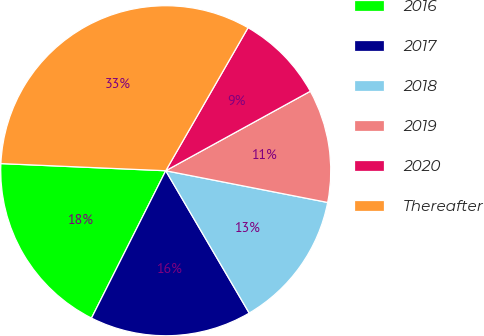<chart> <loc_0><loc_0><loc_500><loc_500><pie_chart><fcel>2016<fcel>2017<fcel>2018<fcel>2019<fcel>2020<fcel>Thereafter<nl><fcel>18.26%<fcel>15.87%<fcel>13.48%<fcel>11.08%<fcel>8.69%<fcel>32.62%<nl></chart> 